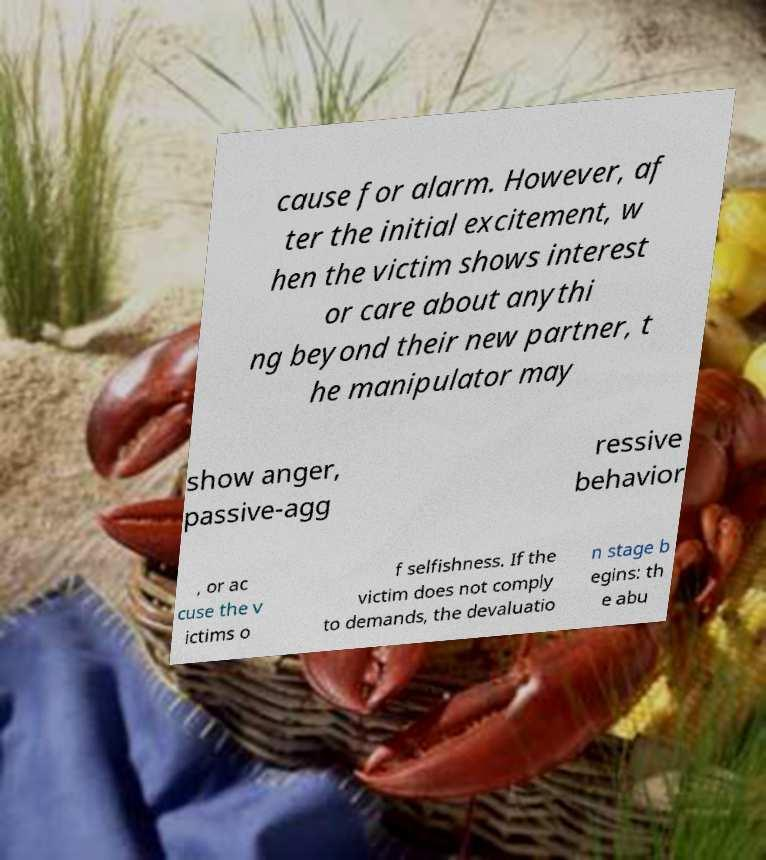Please read and relay the text visible in this image. What does it say? cause for alarm. However, af ter the initial excitement, w hen the victim shows interest or care about anythi ng beyond their new partner, t he manipulator may show anger, passive-agg ressive behavior , or ac cuse the v ictims o f selfishness. If the victim does not comply to demands, the devaluatio n stage b egins: th e abu 